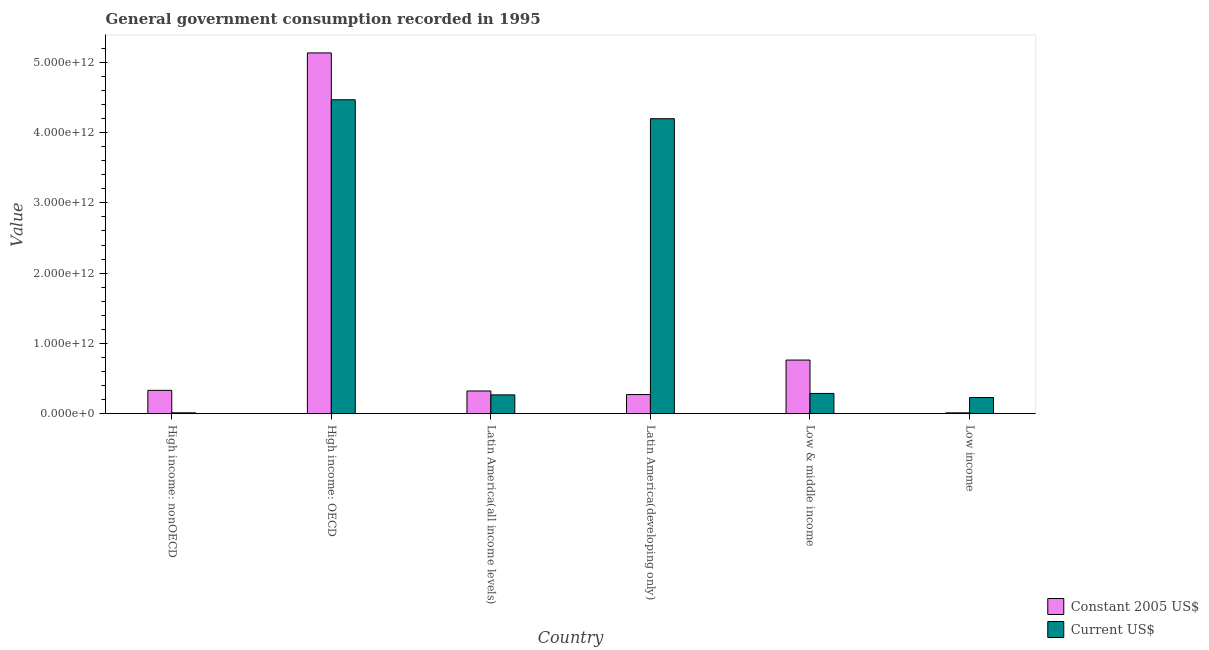How many different coloured bars are there?
Your answer should be very brief. 2. Are the number of bars on each tick of the X-axis equal?
Keep it short and to the point. Yes. How many bars are there on the 2nd tick from the left?
Offer a terse response. 2. What is the label of the 1st group of bars from the left?
Provide a succinct answer. High income: nonOECD. In how many cases, is the number of bars for a given country not equal to the number of legend labels?
Make the answer very short. 0. What is the value consumed in constant 2005 us$ in Latin America(developing only)?
Give a very brief answer. 2.73e+11. Across all countries, what is the maximum value consumed in constant 2005 us$?
Give a very brief answer. 5.13e+12. Across all countries, what is the minimum value consumed in current us$?
Make the answer very short. 1.33e+1. In which country was the value consumed in constant 2005 us$ maximum?
Keep it short and to the point. High income: OECD. In which country was the value consumed in constant 2005 us$ minimum?
Ensure brevity in your answer.  Low income. What is the total value consumed in constant 2005 us$ in the graph?
Your response must be concise. 6.84e+12. What is the difference between the value consumed in current us$ in High income: OECD and that in Latin America(developing only)?
Keep it short and to the point. 2.69e+11. What is the difference between the value consumed in constant 2005 us$ in High income: OECD and the value consumed in current us$ in Latin America(developing only)?
Your answer should be very brief. 9.36e+11. What is the average value consumed in constant 2005 us$ per country?
Offer a very short reply. 1.14e+12. What is the difference between the value consumed in current us$ and value consumed in constant 2005 us$ in Low & middle income?
Your response must be concise. -4.75e+11. In how many countries, is the value consumed in constant 2005 us$ greater than 1200000000000 ?
Your answer should be very brief. 1. What is the ratio of the value consumed in constant 2005 us$ in High income: nonOECD to that in Latin America(all income levels)?
Make the answer very short. 1.03. Is the value consumed in current us$ in High income: nonOECD less than that in Latin America(all income levels)?
Your answer should be very brief. Yes. What is the difference between the highest and the second highest value consumed in current us$?
Provide a short and direct response. 2.69e+11. What is the difference between the highest and the lowest value consumed in constant 2005 us$?
Your answer should be very brief. 5.12e+12. In how many countries, is the value consumed in constant 2005 us$ greater than the average value consumed in constant 2005 us$ taken over all countries?
Offer a terse response. 1. What does the 2nd bar from the left in Latin America(developing only) represents?
Offer a terse response. Current US$. What does the 1st bar from the right in High income: nonOECD represents?
Your answer should be compact. Current US$. How many bars are there?
Make the answer very short. 12. What is the difference between two consecutive major ticks on the Y-axis?
Offer a terse response. 1.00e+12. Are the values on the major ticks of Y-axis written in scientific E-notation?
Provide a succinct answer. Yes. Does the graph contain any zero values?
Provide a short and direct response. No. Does the graph contain grids?
Provide a short and direct response. No. What is the title of the graph?
Keep it short and to the point. General government consumption recorded in 1995. Does "Mobile cellular" appear as one of the legend labels in the graph?
Your answer should be compact. No. What is the label or title of the Y-axis?
Keep it short and to the point. Value. What is the Value in Constant 2005 US$ in High income: nonOECD?
Keep it short and to the point. 3.33e+11. What is the Value in Current US$ in High income: nonOECD?
Give a very brief answer. 1.33e+1. What is the Value in Constant 2005 US$ in High income: OECD?
Make the answer very short. 5.13e+12. What is the Value of Current US$ in High income: OECD?
Provide a short and direct response. 4.47e+12. What is the Value of Constant 2005 US$ in Latin America(all income levels)?
Keep it short and to the point. 3.24e+11. What is the Value of Current US$ in Latin America(all income levels)?
Offer a very short reply. 2.68e+11. What is the Value of Constant 2005 US$ in Latin America(developing only)?
Ensure brevity in your answer.  2.73e+11. What is the Value in Current US$ in Latin America(developing only)?
Your response must be concise. 4.20e+12. What is the Value of Constant 2005 US$ in Low & middle income?
Your response must be concise. 7.64e+11. What is the Value in Current US$ in Low & middle income?
Your answer should be compact. 2.89e+11. What is the Value in Constant 2005 US$ in Low income?
Make the answer very short. 1.29e+1. What is the Value of Current US$ in Low income?
Offer a terse response. 2.30e+11. Across all countries, what is the maximum Value in Constant 2005 US$?
Offer a terse response. 5.13e+12. Across all countries, what is the maximum Value in Current US$?
Provide a succinct answer. 4.47e+12. Across all countries, what is the minimum Value in Constant 2005 US$?
Give a very brief answer. 1.29e+1. Across all countries, what is the minimum Value of Current US$?
Offer a terse response. 1.33e+1. What is the total Value in Constant 2005 US$ in the graph?
Your response must be concise. 6.84e+12. What is the total Value of Current US$ in the graph?
Your answer should be compact. 9.46e+12. What is the difference between the Value in Constant 2005 US$ in High income: nonOECD and that in High income: OECD?
Provide a short and direct response. -4.80e+12. What is the difference between the Value of Current US$ in High income: nonOECD and that in High income: OECD?
Offer a very short reply. -4.45e+12. What is the difference between the Value in Constant 2005 US$ in High income: nonOECD and that in Latin America(all income levels)?
Provide a succinct answer. 8.97e+09. What is the difference between the Value of Current US$ in High income: nonOECD and that in Latin America(all income levels)?
Your response must be concise. -2.55e+11. What is the difference between the Value in Constant 2005 US$ in High income: nonOECD and that in Latin America(developing only)?
Make the answer very short. 5.98e+1. What is the difference between the Value in Current US$ in High income: nonOECD and that in Latin America(developing only)?
Keep it short and to the point. -4.18e+12. What is the difference between the Value in Constant 2005 US$ in High income: nonOECD and that in Low & middle income?
Your response must be concise. -4.31e+11. What is the difference between the Value in Current US$ in High income: nonOECD and that in Low & middle income?
Provide a short and direct response. -2.75e+11. What is the difference between the Value in Constant 2005 US$ in High income: nonOECD and that in Low income?
Provide a short and direct response. 3.20e+11. What is the difference between the Value of Current US$ in High income: nonOECD and that in Low income?
Offer a terse response. -2.17e+11. What is the difference between the Value of Constant 2005 US$ in High income: OECD and that in Latin America(all income levels)?
Ensure brevity in your answer.  4.81e+12. What is the difference between the Value in Current US$ in High income: OECD and that in Latin America(all income levels)?
Offer a very short reply. 4.20e+12. What is the difference between the Value in Constant 2005 US$ in High income: OECD and that in Latin America(developing only)?
Offer a very short reply. 4.86e+12. What is the difference between the Value in Current US$ in High income: OECD and that in Latin America(developing only)?
Ensure brevity in your answer.  2.69e+11. What is the difference between the Value in Constant 2005 US$ in High income: OECD and that in Low & middle income?
Your answer should be very brief. 4.37e+12. What is the difference between the Value in Current US$ in High income: OECD and that in Low & middle income?
Make the answer very short. 4.18e+12. What is the difference between the Value in Constant 2005 US$ in High income: OECD and that in Low income?
Your response must be concise. 5.12e+12. What is the difference between the Value of Current US$ in High income: OECD and that in Low income?
Ensure brevity in your answer.  4.24e+12. What is the difference between the Value of Constant 2005 US$ in Latin America(all income levels) and that in Latin America(developing only)?
Your answer should be very brief. 5.08e+1. What is the difference between the Value of Current US$ in Latin America(all income levels) and that in Latin America(developing only)?
Your response must be concise. -3.93e+12. What is the difference between the Value of Constant 2005 US$ in Latin America(all income levels) and that in Low & middle income?
Your answer should be compact. -4.40e+11. What is the difference between the Value in Current US$ in Latin America(all income levels) and that in Low & middle income?
Keep it short and to the point. -2.05e+1. What is the difference between the Value of Constant 2005 US$ in Latin America(all income levels) and that in Low income?
Offer a very short reply. 3.11e+11. What is the difference between the Value of Current US$ in Latin America(all income levels) and that in Low income?
Ensure brevity in your answer.  3.80e+1. What is the difference between the Value of Constant 2005 US$ in Latin America(developing only) and that in Low & middle income?
Your response must be concise. -4.91e+11. What is the difference between the Value in Current US$ in Latin America(developing only) and that in Low & middle income?
Make the answer very short. 3.91e+12. What is the difference between the Value of Constant 2005 US$ in Latin America(developing only) and that in Low income?
Make the answer very short. 2.60e+11. What is the difference between the Value in Current US$ in Latin America(developing only) and that in Low income?
Make the answer very short. 3.97e+12. What is the difference between the Value in Constant 2005 US$ in Low & middle income and that in Low income?
Offer a terse response. 7.51e+11. What is the difference between the Value in Current US$ in Low & middle income and that in Low income?
Give a very brief answer. 5.85e+1. What is the difference between the Value in Constant 2005 US$ in High income: nonOECD and the Value in Current US$ in High income: OECD?
Provide a succinct answer. -4.13e+12. What is the difference between the Value in Constant 2005 US$ in High income: nonOECD and the Value in Current US$ in Latin America(all income levels)?
Your response must be concise. 6.44e+1. What is the difference between the Value in Constant 2005 US$ in High income: nonOECD and the Value in Current US$ in Latin America(developing only)?
Make the answer very short. -3.86e+12. What is the difference between the Value in Constant 2005 US$ in High income: nonOECD and the Value in Current US$ in Low & middle income?
Offer a terse response. 4.39e+1. What is the difference between the Value in Constant 2005 US$ in High income: nonOECD and the Value in Current US$ in Low income?
Offer a very short reply. 1.02e+11. What is the difference between the Value in Constant 2005 US$ in High income: OECD and the Value in Current US$ in Latin America(all income levels)?
Your answer should be compact. 4.86e+12. What is the difference between the Value of Constant 2005 US$ in High income: OECD and the Value of Current US$ in Latin America(developing only)?
Offer a very short reply. 9.36e+11. What is the difference between the Value in Constant 2005 US$ in High income: OECD and the Value in Current US$ in Low & middle income?
Keep it short and to the point. 4.84e+12. What is the difference between the Value of Constant 2005 US$ in High income: OECD and the Value of Current US$ in Low income?
Provide a short and direct response. 4.90e+12. What is the difference between the Value in Constant 2005 US$ in Latin America(all income levels) and the Value in Current US$ in Latin America(developing only)?
Your response must be concise. -3.87e+12. What is the difference between the Value of Constant 2005 US$ in Latin America(all income levels) and the Value of Current US$ in Low & middle income?
Make the answer very short. 3.50e+1. What is the difference between the Value in Constant 2005 US$ in Latin America(all income levels) and the Value in Current US$ in Low income?
Keep it short and to the point. 9.35e+1. What is the difference between the Value in Constant 2005 US$ in Latin America(developing only) and the Value in Current US$ in Low & middle income?
Your response must be concise. -1.58e+1. What is the difference between the Value of Constant 2005 US$ in Latin America(developing only) and the Value of Current US$ in Low income?
Your answer should be very brief. 4.27e+1. What is the difference between the Value of Constant 2005 US$ in Low & middle income and the Value of Current US$ in Low income?
Your answer should be very brief. 5.33e+11. What is the average Value in Constant 2005 US$ per country?
Give a very brief answer. 1.14e+12. What is the average Value in Current US$ per country?
Ensure brevity in your answer.  1.58e+12. What is the difference between the Value of Constant 2005 US$ and Value of Current US$ in High income: nonOECD?
Your answer should be very brief. 3.19e+11. What is the difference between the Value of Constant 2005 US$ and Value of Current US$ in High income: OECD?
Give a very brief answer. 6.66e+11. What is the difference between the Value of Constant 2005 US$ and Value of Current US$ in Latin America(all income levels)?
Offer a very short reply. 5.54e+1. What is the difference between the Value of Constant 2005 US$ and Value of Current US$ in Latin America(developing only)?
Ensure brevity in your answer.  -3.92e+12. What is the difference between the Value of Constant 2005 US$ and Value of Current US$ in Low & middle income?
Provide a succinct answer. 4.75e+11. What is the difference between the Value in Constant 2005 US$ and Value in Current US$ in Low income?
Your answer should be very brief. -2.17e+11. What is the ratio of the Value of Constant 2005 US$ in High income: nonOECD to that in High income: OECD?
Offer a terse response. 0.06. What is the ratio of the Value of Current US$ in High income: nonOECD to that in High income: OECD?
Your answer should be very brief. 0. What is the ratio of the Value of Constant 2005 US$ in High income: nonOECD to that in Latin America(all income levels)?
Provide a succinct answer. 1.03. What is the ratio of the Value of Current US$ in High income: nonOECD to that in Latin America(all income levels)?
Ensure brevity in your answer.  0.05. What is the ratio of the Value of Constant 2005 US$ in High income: nonOECD to that in Latin America(developing only)?
Your answer should be very brief. 1.22. What is the ratio of the Value of Current US$ in High income: nonOECD to that in Latin America(developing only)?
Give a very brief answer. 0. What is the ratio of the Value of Constant 2005 US$ in High income: nonOECD to that in Low & middle income?
Offer a terse response. 0.44. What is the ratio of the Value in Current US$ in High income: nonOECD to that in Low & middle income?
Your response must be concise. 0.05. What is the ratio of the Value in Constant 2005 US$ in High income: nonOECD to that in Low income?
Keep it short and to the point. 25.8. What is the ratio of the Value of Current US$ in High income: nonOECD to that in Low income?
Your answer should be very brief. 0.06. What is the ratio of the Value in Constant 2005 US$ in High income: OECD to that in Latin America(all income levels)?
Provide a succinct answer. 15.85. What is the ratio of the Value of Current US$ in High income: OECD to that in Latin America(all income levels)?
Provide a short and direct response. 16.65. What is the ratio of the Value of Constant 2005 US$ in High income: OECD to that in Latin America(developing only)?
Offer a terse response. 18.8. What is the ratio of the Value in Current US$ in High income: OECD to that in Latin America(developing only)?
Offer a terse response. 1.06. What is the ratio of the Value in Constant 2005 US$ in High income: OECD to that in Low & middle income?
Your answer should be very brief. 6.72. What is the ratio of the Value in Current US$ in High income: OECD to that in Low & middle income?
Ensure brevity in your answer.  15.47. What is the ratio of the Value of Constant 2005 US$ in High income: OECD to that in Low income?
Your answer should be very brief. 398.09. What is the ratio of the Value in Current US$ in High income: OECD to that in Low income?
Your answer should be very brief. 19.4. What is the ratio of the Value in Constant 2005 US$ in Latin America(all income levels) to that in Latin America(developing only)?
Keep it short and to the point. 1.19. What is the ratio of the Value in Current US$ in Latin America(all income levels) to that in Latin America(developing only)?
Your response must be concise. 0.06. What is the ratio of the Value of Constant 2005 US$ in Latin America(all income levels) to that in Low & middle income?
Offer a very short reply. 0.42. What is the ratio of the Value in Current US$ in Latin America(all income levels) to that in Low & middle income?
Provide a short and direct response. 0.93. What is the ratio of the Value in Constant 2005 US$ in Latin America(all income levels) to that in Low income?
Keep it short and to the point. 25.11. What is the ratio of the Value in Current US$ in Latin America(all income levels) to that in Low income?
Offer a very short reply. 1.17. What is the ratio of the Value in Constant 2005 US$ in Latin America(developing only) to that in Low & middle income?
Ensure brevity in your answer.  0.36. What is the ratio of the Value of Current US$ in Latin America(developing only) to that in Low & middle income?
Ensure brevity in your answer.  14.53. What is the ratio of the Value of Constant 2005 US$ in Latin America(developing only) to that in Low income?
Ensure brevity in your answer.  21.17. What is the ratio of the Value in Current US$ in Latin America(developing only) to that in Low income?
Your response must be concise. 18.23. What is the ratio of the Value in Constant 2005 US$ in Low & middle income to that in Low income?
Provide a short and direct response. 59.22. What is the ratio of the Value of Current US$ in Low & middle income to that in Low income?
Offer a very short reply. 1.25. What is the difference between the highest and the second highest Value in Constant 2005 US$?
Keep it short and to the point. 4.37e+12. What is the difference between the highest and the second highest Value of Current US$?
Offer a terse response. 2.69e+11. What is the difference between the highest and the lowest Value in Constant 2005 US$?
Make the answer very short. 5.12e+12. What is the difference between the highest and the lowest Value of Current US$?
Your response must be concise. 4.45e+12. 